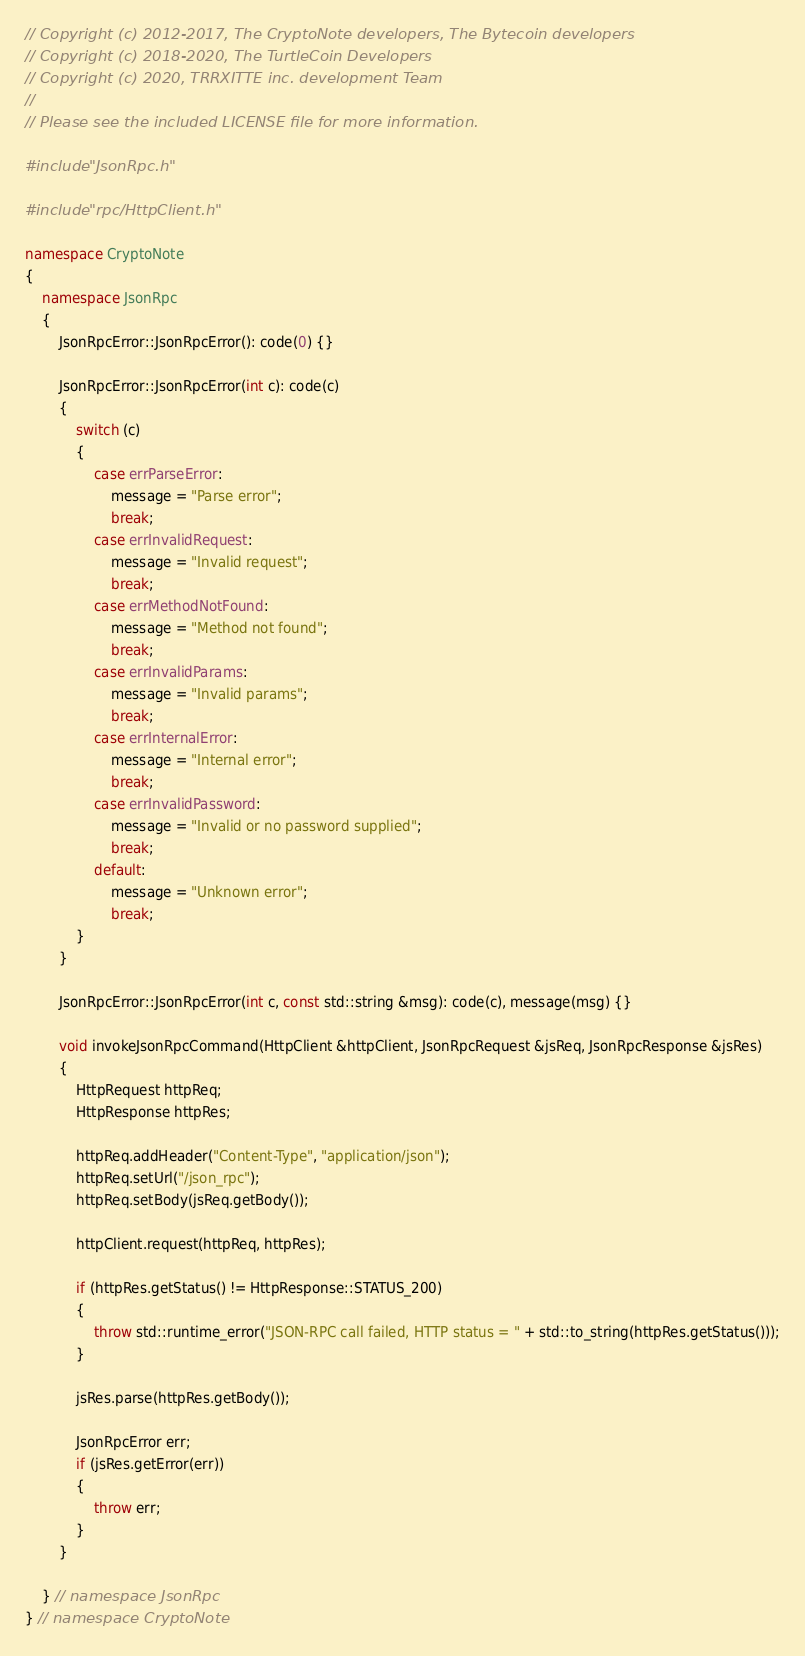<code> <loc_0><loc_0><loc_500><loc_500><_C++_>// Copyright (c) 2012-2017, The CryptoNote developers, The Bytecoin developers
// Copyright (c) 2018-2020, The TurtleCoin Developers
// Copyright (c) 2020, TRRXITTE inc. development Team
//
// Please see the included LICENSE file for more information.

#include "JsonRpc.h"

#include "rpc/HttpClient.h"

namespace CryptoNote
{
    namespace JsonRpc
    {
        JsonRpcError::JsonRpcError(): code(0) {}

        JsonRpcError::JsonRpcError(int c): code(c)
        {
            switch (c)
            {
                case errParseError:
                    message = "Parse error";
                    break;
                case errInvalidRequest:
                    message = "Invalid request";
                    break;
                case errMethodNotFound:
                    message = "Method not found";
                    break;
                case errInvalidParams:
                    message = "Invalid params";
                    break;
                case errInternalError:
                    message = "Internal error";
                    break;
                case errInvalidPassword:
                    message = "Invalid or no password supplied";
                    break;
                default:
                    message = "Unknown error";
                    break;
            }
        }

        JsonRpcError::JsonRpcError(int c, const std::string &msg): code(c), message(msg) {}

        void invokeJsonRpcCommand(HttpClient &httpClient, JsonRpcRequest &jsReq, JsonRpcResponse &jsRes)
        {
            HttpRequest httpReq;
            HttpResponse httpRes;

            httpReq.addHeader("Content-Type", "application/json");
            httpReq.setUrl("/json_rpc");
            httpReq.setBody(jsReq.getBody());

            httpClient.request(httpReq, httpRes);

            if (httpRes.getStatus() != HttpResponse::STATUS_200)
            {
                throw std::runtime_error("JSON-RPC call failed, HTTP status = " + std::to_string(httpRes.getStatus()));
            }

            jsRes.parse(httpRes.getBody());

            JsonRpcError err;
            if (jsRes.getError(err))
            {
                throw err;
            }
        }

    } // namespace JsonRpc
} // namespace CryptoNote
</code> 